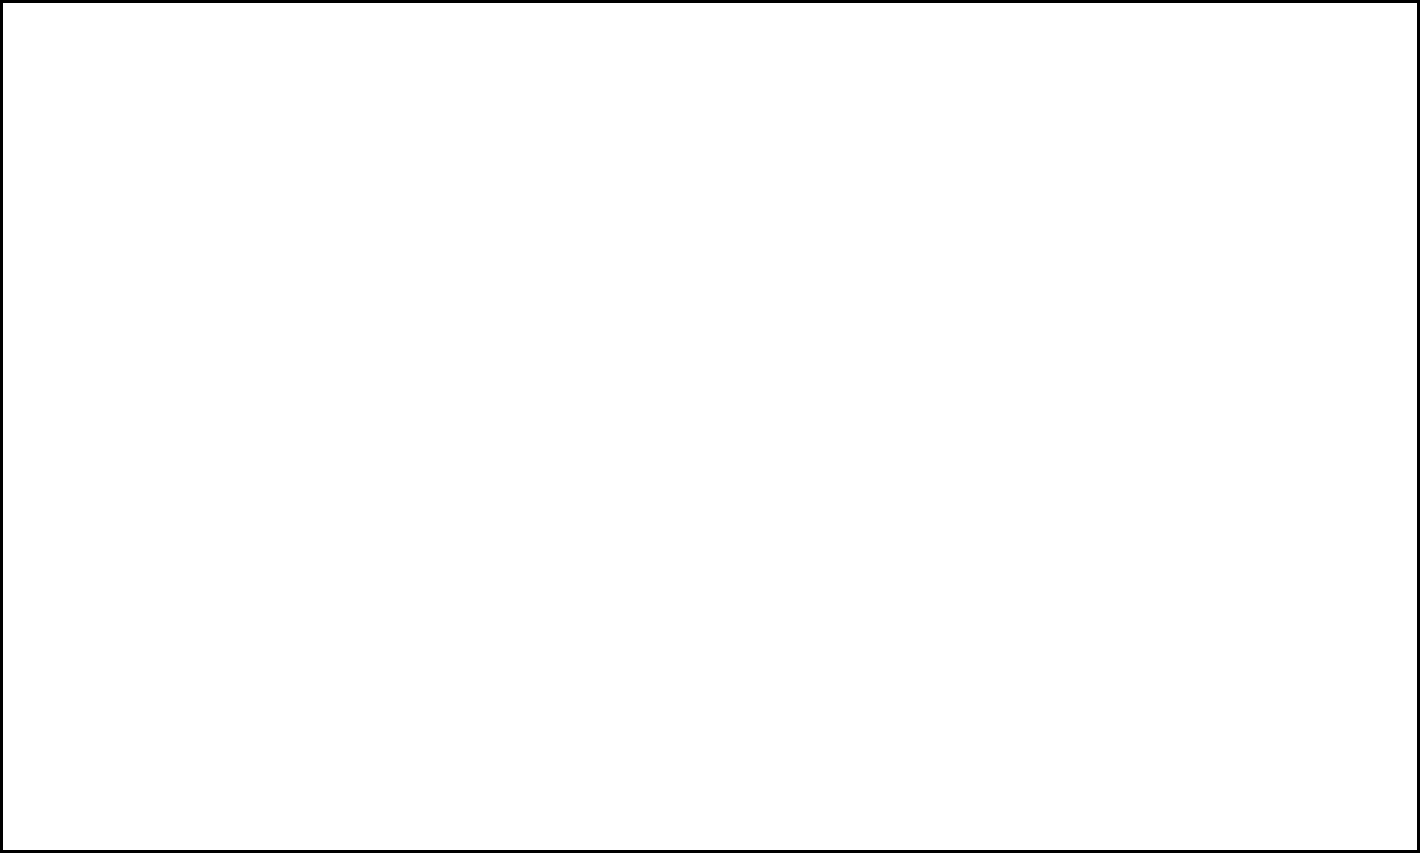Examine the world map with concentric circles representing the spread of cultural influence from a central point A. If the time taken for cultural elements to spread from one circle to the next is approximately 50 years, and significant cultural assimilation occurs when an area has been exposed to the influence for at least 100 years, in how many years would region D experience significant cultural assimilation from the source at point A? To solve this problem, we need to follow these steps:

1. Understand the given information:
   - The concentric circles represent the spread of cultural influence.
   - Each circle takes about 50 years to spread to the next.
   - Significant cultural assimilation occurs after 100 years of exposure.

2. Count the number of circles from point A to region D:
   - A to B: 1 circle
   - B to C: 1 circle
   - C to D: 1 circle
   - Total: 3 circles

3. Calculate the time for cultural influence to reach region D:
   - Time = Number of circles × Time per circle
   - Time = 3 × 50 years = 150 years

4. Determine the additional time needed for significant cultural assimilation:
   - Since significant assimilation occurs after 100 years of exposure, we need to add 100 years to the time it takes for the influence to reach region D.

5. Calculate the total time for significant cultural assimilation in region D:
   - Total time = Time to reach region D + Time for significant assimilation
   - Total time = 150 years + 100 years = 250 years

Therefore, it would take 250 years for region D to experience significant cultural assimilation from the source at point A.
Answer: 250 years 